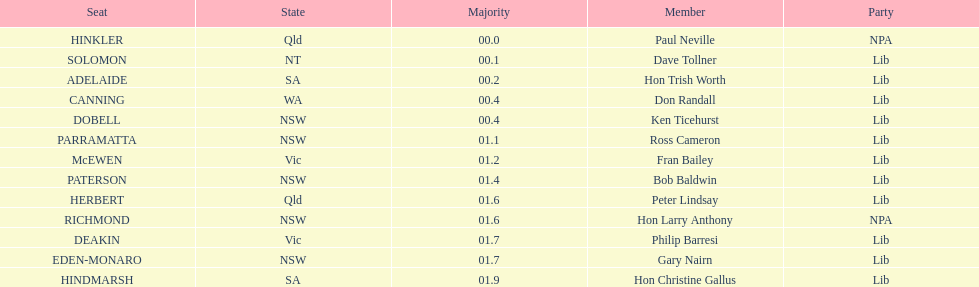Which seats are represented in the electoral system of australia? HINKLER, SOLOMON, ADELAIDE, CANNING, DOBELL, PARRAMATTA, McEWEN, PATERSON, HERBERT, RICHMOND, DEAKIN, EDEN-MONARO, HINDMARSH. What were their majority numbers of both hindmarsh and hinkler? HINKLER, HINDMARSH. Of those two seats, what is the difference in voting majority? 01.9. 